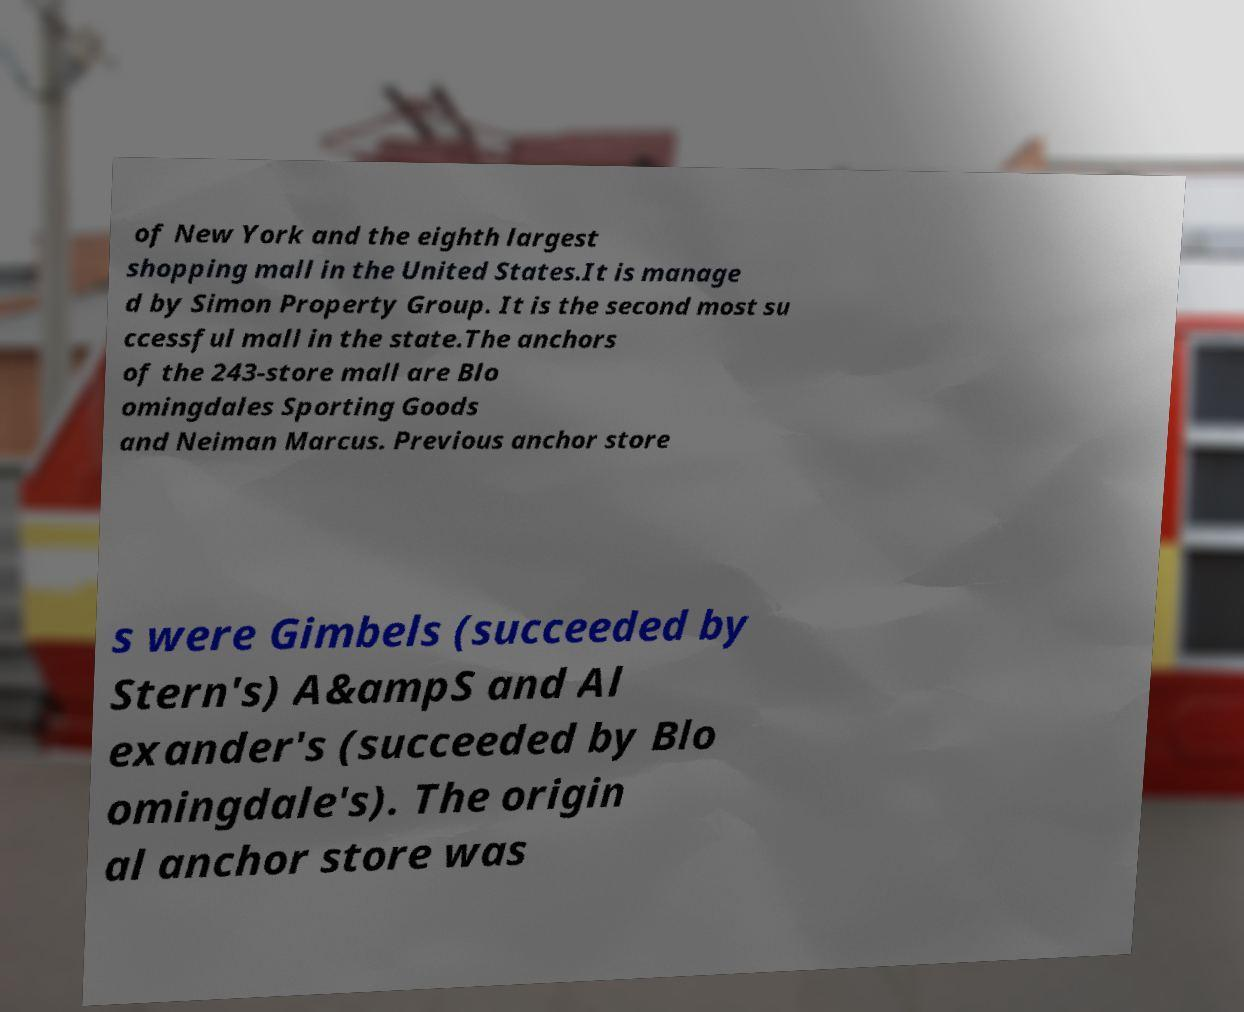Could you extract and type out the text from this image? of New York and the eighth largest shopping mall in the United States.It is manage d by Simon Property Group. It is the second most su ccessful mall in the state.The anchors of the 243-store mall are Blo omingdales Sporting Goods and Neiman Marcus. Previous anchor store s were Gimbels (succeeded by Stern's) A&ampS and Al exander's (succeeded by Blo omingdale's). The origin al anchor store was 